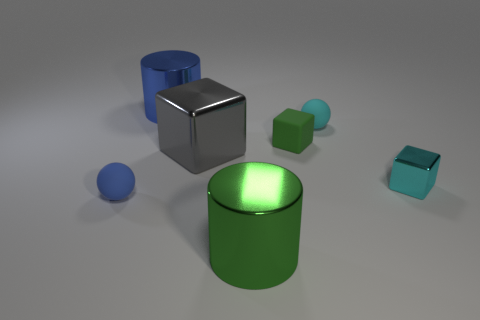There is a small cyan thing that is the same shape as the large gray thing; what material is it?
Your response must be concise. Metal. What color is the ball to the left of the metal thing behind the gray block behind the green cylinder?
Offer a terse response. Blue. There is a cyan object that is the same material as the gray thing; what shape is it?
Give a very brief answer. Cube. Is the number of small blue things less than the number of purple spheres?
Your answer should be compact. No. Are the big blue cylinder and the small cyan cube made of the same material?
Your answer should be very brief. Yes. How many other objects are there of the same color as the big metal block?
Provide a short and direct response. 0. Is the number of green things greater than the number of small green rubber objects?
Your response must be concise. Yes. Is the size of the matte block the same as the metallic cylinder in front of the small metal block?
Give a very brief answer. No. What color is the shiny block that is to the left of the green shiny cylinder?
Your answer should be compact. Gray. How many green things are small blocks or metallic cubes?
Make the answer very short. 1. 